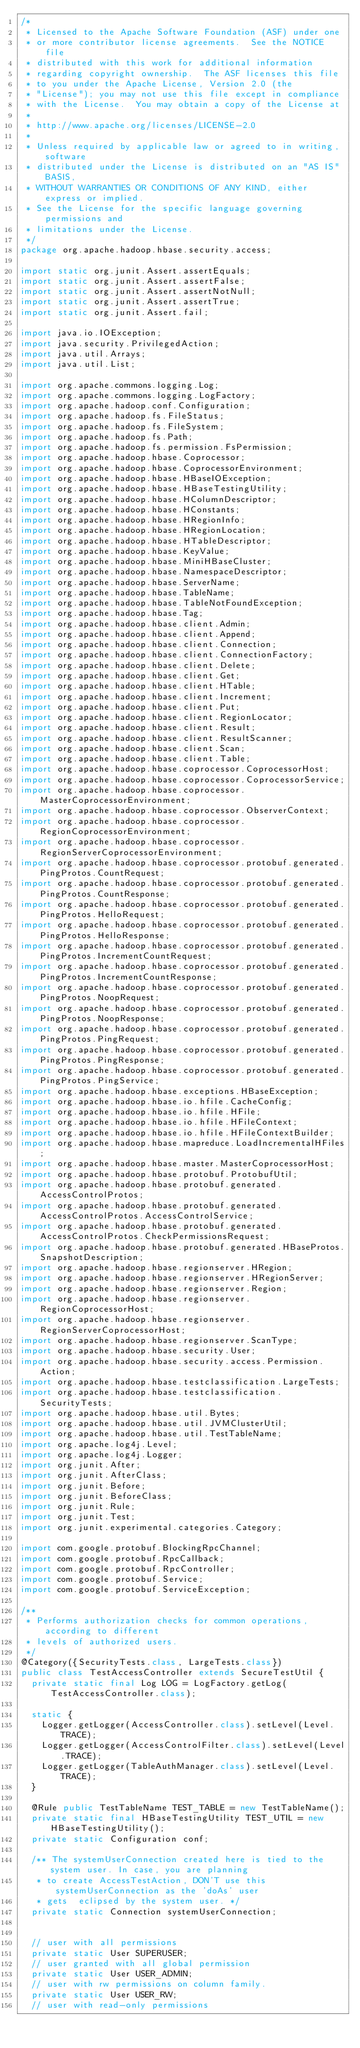<code> <loc_0><loc_0><loc_500><loc_500><_Java_>/*
 * Licensed to the Apache Software Foundation (ASF) under one
 * or more contributor license agreements.  See the NOTICE file
 * distributed with this work for additional information
 * regarding copyright ownership.  The ASF licenses this file
 * to you under the Apache License, Version 2.0 (the
 * "License"); you may not use this file except in compliance
 * with the License.  You may obtain a copy of the License at
 *
 * http://www.apache.org/licenses/LICENSE-2.0
 *
 * Unless required by applicable law or agreed to in writing, software
 * distributed under the License is distributed on an "AS IS" BASIS,
 * WITHOUT WARRANTIES OR CONDITIONS OF ANY KIND, either express or implied.
 * See the License for the specific language governing permissions and
 * limitations under the License.
 */
package org.apache.hadoop.hbase.security.access;

import static org.junit.Assert.assertEquals;
import static org.junit.Assert.assertFalse;
import static org.junit.Assert.assertNotNull;
import static org.junit.Assert.assertTrue;
import static org.junit.Assert.fail;

import java.io.IOException;
import java.security.PrivilegedAction;
import java.util.Arrays;
import java.util.List;

import org.apache.commons.logging.Log;
import org.apache.commons.logging.LogFactory;
import org.apache.hadoop.conf.Configuration;
import org.apache.hadoop.fs.FileStatus;
import org.apache.hadoop.fs.FileSystem;
import org.apache.hadoop.fs.Path;
import org.apache.hadoop.fs.permission.FsPermission;
import org.apache.hadoop.hbase.Coprocessor;
import org.apache.hadoop.hbase.CoprocessorEnvironment;
import org.apache.hadoop.hbase.HBaseIOException;
import org.apache.hadoop.hbase.HBaseTestingUtility;
import org.apache.hadoop.hbase.HColumnDescriptor;
import org.apache.hadoop.hbase.HConstants;
import org.apache.hadoop.hbase.HRegionInfo;
import org.apache.hadoop.hbase.HRegionLocation;
import org.apache.hadoop.hbase.HTableDescriptor;
import org.apache.hadoop.hbase.KeyValue;
import org.apache.hadoop.hbase.MiniHBaseCluster;
import org.apache.hadoop.hbase.NamespaceDescriptor;
import org.apache.hadoop.hbase.ServerName;
import org.apache.hadoop.hbase.TableName;
import org.apache.hadoop.hbase.TableNotFoundException;
import org.apache.hadoop.hbase.Tag;
import org.apache.hadoop.hbase.client.Admin;
import org.apache.hadoop.hbase.client.Append;
import org.apache.hadoop.hbase.client.Connection;
import org.apache.hadoop.hbase.client.ConnectionFactory;
import org.apache.hadoop.hbase.client.Delete;
import org.apache.hadoop.hbase.client.Get;
import org.apache.hadoop.hbase.client.HTable;
import org.apache.hadoop.hbase.client.Increment;
import org.apache.hadoop.hbase.client.Put;
import org.apache.hadoop.hbase.client.RegionLocator;
import org.apache.hadoop.hbase.client.Result;
import org.apache.hadoop.hbase.client.ResultScanner;
import org.apache.hadoop.hbase.client.Scan;
import org.apache.hadoop.hbase.client.Table;
import org.apache.hadoop.hbase.coprocessor.CoprocessorHost;
import org.apache.hadoop.hbase.coprocessor.CoprocessorService;
import org.apache.hadoop.hbase.coprocessor.MasterCoprocessorEnvironment;
import org.apache.hadoop.hbase.coprocessor.ObserverContext;
import org.apache.hadoop.hbase.coprocessor.RegionCoprocessorEnvironment;
import org.apache.hadoop.hbase.coprocessor.RegionServerCoprocessorEnvironment;
import org.apache.hadoop.hbase.coprocessor.protobuf.generated.PingProtos.CountRequest;
import org.apache.hadoop.hbase.coprocessor.protobuf.generated.PingProtos.CountResponse;
import org.apache.hadoop.hbase.coprocessor.protobuf.generated.PingProtos.HelloRequest;
import org.apache.hadoop.hbase.coprocessor.protobuf.generated.PingProtos.HelloResponse;
import org.apache.hadoop.hbase.coprocessor.protobuf.generated.PingProtos.IncrementCountRequest;
import org.apache.hadoop.hbase.coprocessor.protobuf.generated.PingProtos.IncrementCountResponse;
import org.apache.hadoop.hbase.coprocessor.protobuf.generated.PingProtos.NoopRequest;
import org.apache.hadoop.hbase.coprocessor.protobuf.generated.PingProtos.NoopResponse;
import org.apache.hadoop.hbase.coprocessor.protobuf.generated.PingProtos.PingRequest;
import org.apache.hadoop.hbase.coprocessor.protobuf.generated.PingProtos.PingResponse;
import org.apache.hadoop.hbase.coprocessor.protobuf.generated.PingProtos.PingService;
import org.apache.hadoop.hbase.exceptions.HBaseException;
import org.apache.hadoop.hbase.io.hfile.CacheConfig;
import org.apache.hadoop.hbase.io.hfile.HFile;
import org.apache.hadoop.hbase.io.hfile.HFileContext;
import org.apache.hadoop.hbase.io.hfile.HFileContextBuilder;
import org.apache.hadoop.hbase.mapreduce.LoadIncrementalHFiles;
import org.apache.hadoop.hbase.master.MasterCoprocessorHost;
import org.apache.hadoop.hbase.protobuf.ProtobufUtil;
import org.apache.hadoop.hbase.protobuf.generated.AccessControlProtos;
import org.apache.hadoop.hbase.protobuf.generated.AccessControlProtos.AccessControlService;
import org.apache.hadoop.hbase.protobuf.generated.AccessControlProtos.CheckPermissionsRequest;
import org.apache.hadoop.hbase.protobuf.generated.HBaseProtos.SnapshotDescription;
import org.apache.hadoop.hbase.regionserver.HRegion;
import org.apache.hadoop.hbase.regionserver.HRegionServer;
import org.apache.hadoop.hbase.regionserver.Region;
import org.apache.hadoop.hbase.regionserver.RegionCoprocessorHost;
import org.apache.hadoop.hbase.regionserver.RegionServerCoprocessorHost;
import org.apache.hadoop.hbase.regionserver.ScanType;
import org.apache.hadoop.hbase.security.User;
import org.apache.hadoop.hbase.security.access.Permission.Action;
import org.apache.hadoop.hbase.testclassification.LargeTests;
import org.apache.hadoop.hbase.testclassification.SecurityTests;
import org.apache.hadoop.hbase.util.Bytes;
import org.apache.hadoop.hbase.util.JVMClusterUtil;
import org.apache.hadoop.hbase.util.TestTableName;
import org.apache.log4j.Level;
import org.apache.log4j.Logger;
import org.junit.After;
import org.junit.AfterClass;
import org.junit.Before;
import org.junit.BeforeClass;
import org.junit.Rule;
import org.junit.Test;
import org.junit.experimental.categories.Category;

import com.google.protobuf.BlockingRpcChannel;
import com.google.protobuf.RpcCallback;
import com.google.protobuf.RpcController;
import com.google.protobuf.Service;
import com.google.protobuf.ServiceException;

/**
 * Performs authorization checks for common operations, according to different
 * levels of authorized users.
 */
@Category({SecurityTests.class, LargeTests.class})
public class TestAccessController extends SecureTestUtil {
  private static final Log LOG = LogFactory.getLog(TestAccessController.class);

  static {
    Logger.getLogger(AccessController.class).setLevel(Level.TRACE);
    Logger.getLogger(AccessControlFilter.class).setLevel(Level.TRACE);
    Logger.getLogger(TableAuthManager.class).setLevel(Level.TRACE);
  }

  @Rule public TestTableName TEST_TABLE = new TestTableName();
  private static final HBaseTestingUtility TEST_UTIL = new HBaseTestingUtility();
  private static Configuration conf;

  /** The systemUserConnection created here is tied to the system user. In case, you are planning
   * to create AccessTestAction, DON'T use this systemUserConnection as the 'doAs' user
   * gets  eclipsed by the system user. */
  private static Connection systemUserConnection;


  // user with all permissions
  private static User SUPERUSER;
  // user granted with all global permission
  private static User USER_ADMIN;
  // user with rw permissions on column family.
  private static User USER_RW;
  // user with read-only permissions</code> 